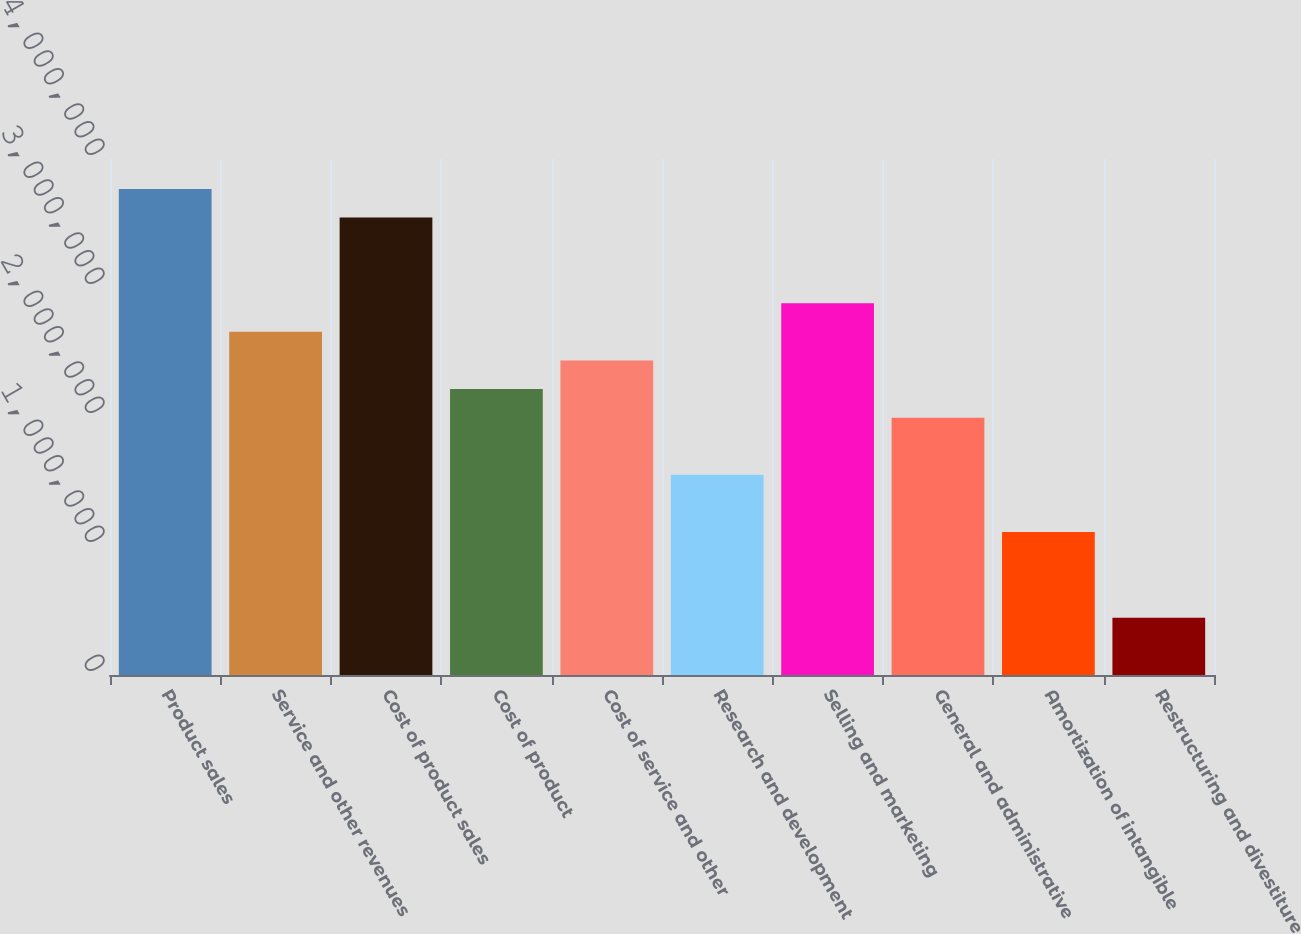Convert chart. <chart><loc_0><loc_0><loc_500><loc_500><bar_chart><fcel>Product sales<fcel>Service and other revenues<fcel>Cost of product sales<fcel>Cost of product<fcel>Cost of service and other<fcel>Research and development<fcel>Selling and marketing<fcel>General and administrative<fcel>Amortization of intangible<fcel>Restructuring and divestiture<nl><fcel>3.76829e+06<fcel>2.65997e+06<fcel>3.54662e+06<fcel>2.21664e+06<fcel>2.43831e+06<fcel>1.55165e+06<fcel>2.88163e+06<fcel>1.99498e+06<fcel>1.10833e+06<fcel>443335<nl></chart> 